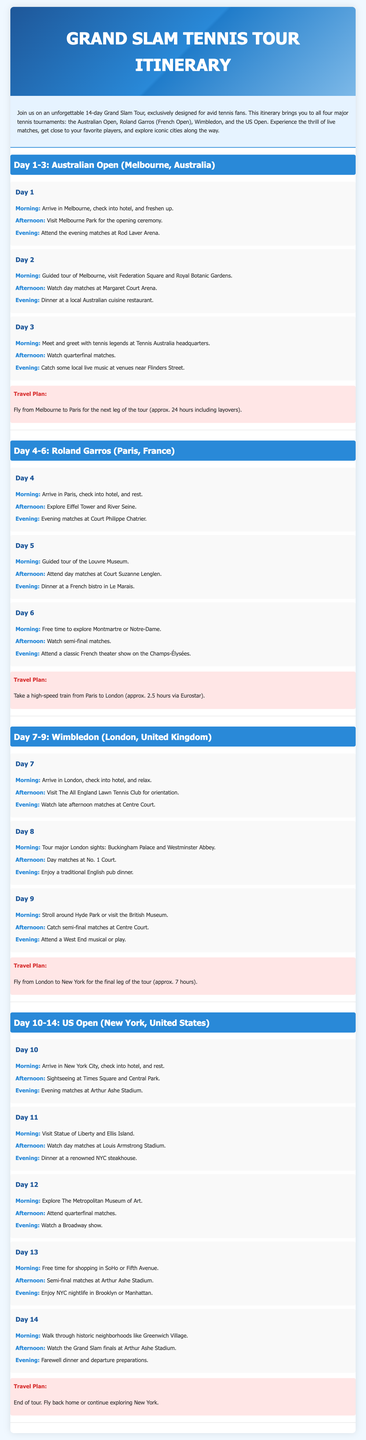What is the duration of the tour? The tour lasts for 14 days, as mentioned in the title and introductory paragraph.
Answer: 14 days Where does the Grand Slam Tour start? The itinerary begins with the Australian Open, which is held in Melbourne, Australia.
Answer: Melbourne, Australia What is planned for Day 2 in Melbourne? Day 2 includes a guided tour of Melbourne, followed by watching day matches at Margaret Court Arena.
Answer: Guided tour and matches at Margaret Court Arena How long is the travel from Paris to London? The document states that the travel time is approximately 2.5 hours via Eurostar.
Answer: 2.5 hours What activities take place on Day 12 in New York City? On Day 12, the plan includes exploring The Metropolitan Museum of Art and attending quarterfinal matches.
Answer: Museum exploration and quarterfinal matches How many matches can be watched in the evenings during the Australian Open? The itinerary mentions attending matches in the evening for Days 1, 2, and 3, suggesting three evenings of matches.
Answer: Three evenings What type of cuisine is recommended for dinner on Day 5? The itinerary suggests dining at a French bistro in Le Marais for dinner.
Answer: French bistro What major activity is scheduled for the last day of the tour? The last day's major activity is watching the Grand Slam finals at Arthur Ashe Stadium.
Answer: Grand Slam finals at Arthur Ashe Stadium What city hosts the US Open? The last tournament of the tour, the US Open, is held in New York City.
Answer: New York City 